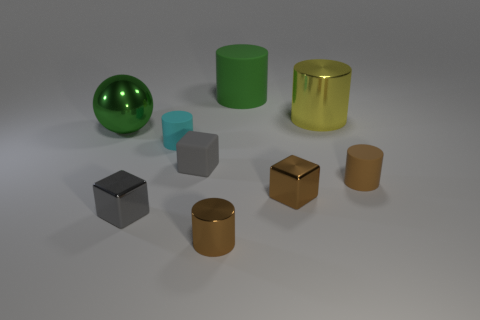How many rubber cylinders are the same color as the sphere?
Your response must be concise. 1. What material is the other cylinder that is the same color as the small shiny cylinder?
Make the answer very short. Rubber. Do the metallic cylinder that is left of the big matte object and the rubber object that is on the right side of the yellow metal cylinder have the same color?
Your answer should be compact. Yes. What number of small metallic blocks are there?
Keep it short and to the point. 2. What is the shape of the large thing that is left of the cyan matte cylinder?
Offer a very short reply. Sphere. The big metallic thing that is to the right of the big object that is left of the rubber object that is behind the sphere is what color?
Your answer should be compact. Yellow. The large green thing that is the same material as the yellow thing is what shape?
Ensure brevity in your answer.  Sphere. Is the number of purple spheres less than the number of brown cylinders?
Offer a terse response. Yes. Is the material of the large ball the same as the large green cylinder?
Give a very brief answer. No. How many other objects are there of the same color as the big rubber object?
Keep it short and to the point. 1. 